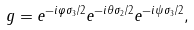Convert formula to latex. <formula><loc_0><loc_0><loc_500><loc_500>g = e ^ { - i \varphi \sigma _ { 3 } / 2 } e ^ { - i \theta \sigma _ { 2 } / 2 } e ^ { - i \psi \sigma _ { 3 } / 2 } ,</formula> 